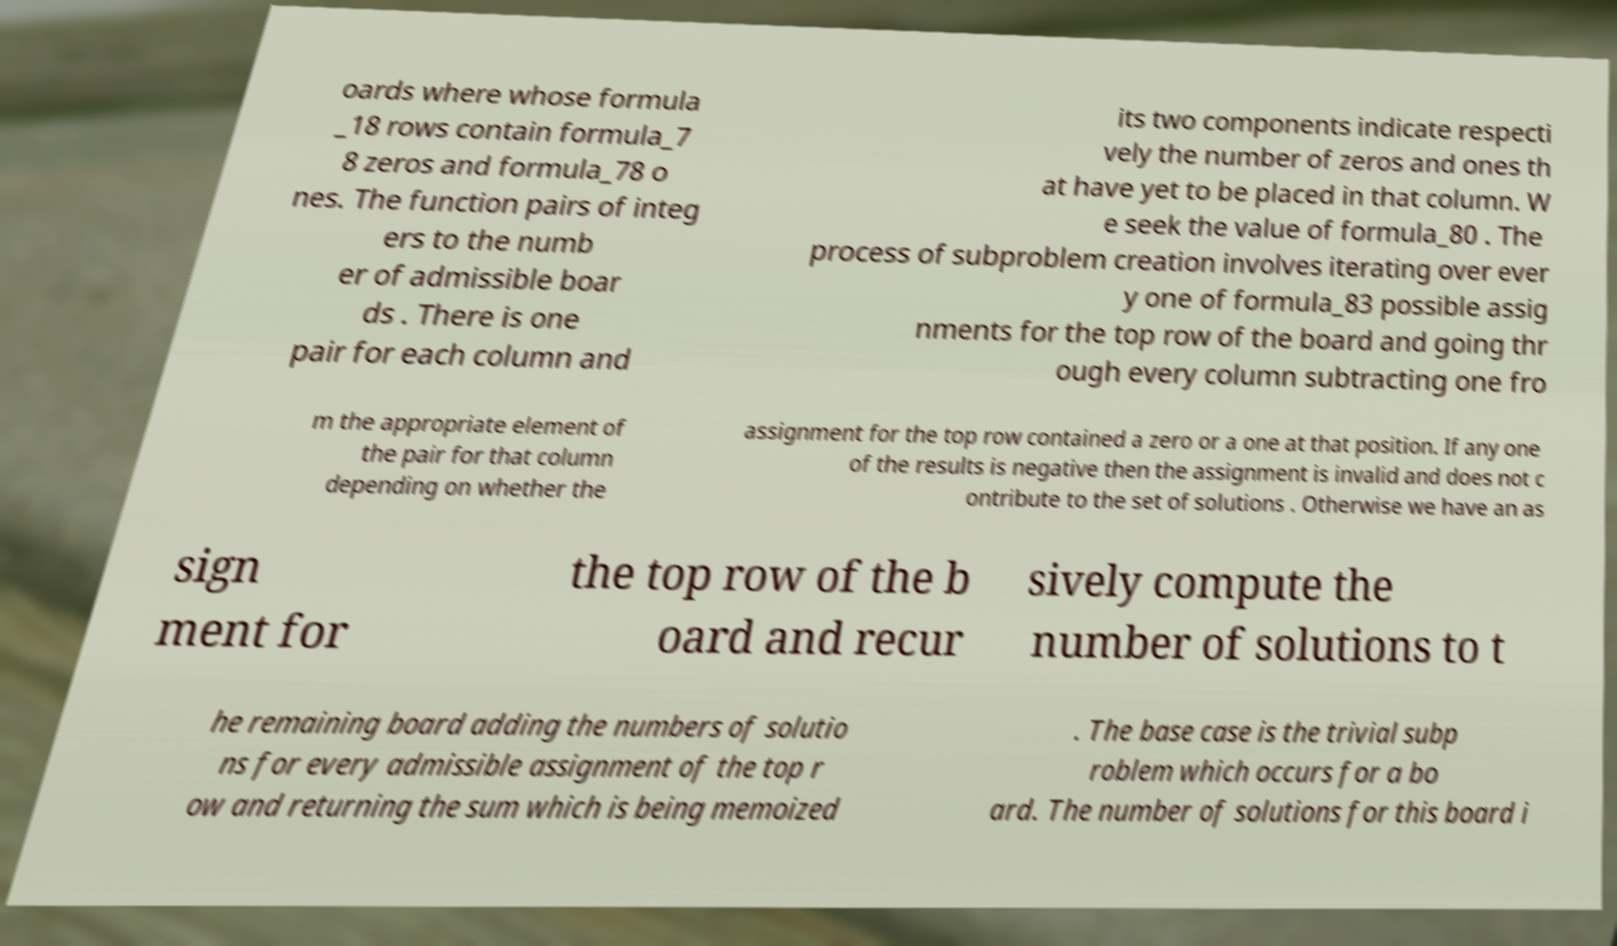Could you extract and type out the text from this image? oards where whose formula _18 rows contain formula_7 8 zeros and formula_78 o nes. The function pairs of integ ers to the numb er of admissible boar ds . There is one pair for each column and its two components indicate respecti vely the number of zeros and ones th at have yet to be placed in that column. W e seek the value of formula_80 . The process of subproblem creation involves iterating over ever y one of formula_83 possible assig nments for the top row of the board and going thr ough every column subtracting one fro m the appropriate element of the pair for that column depending on whether the assignment for the top row contained a zero or a one at that position. If any one of the results is negative then the assignment is invalid and does not c ontribute to the set of solutions . Otherwise we have an as sign ment for the top row of the b oard and recur sively compute the number of solutions to t he remaining board adding the numbers of solutio ns for every admissible assignment of the top r ow and returning the sum which is being memoized . The base case is the trivial subp roblem which occurs for a bo ard. The number of solutions for this board i 